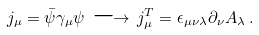<formula> <loc_0><loc_0><loc_500><loc_500>j _ { \mu } = \bar { \psi } \gamma _ { \mu } \psi \, \longrightarrow \, j _ { \mu } ^ { T } = \epsilon _ { \mu \nu \lambda } \partial _ { \nu } A _ { \lambda } \, .</formula> 